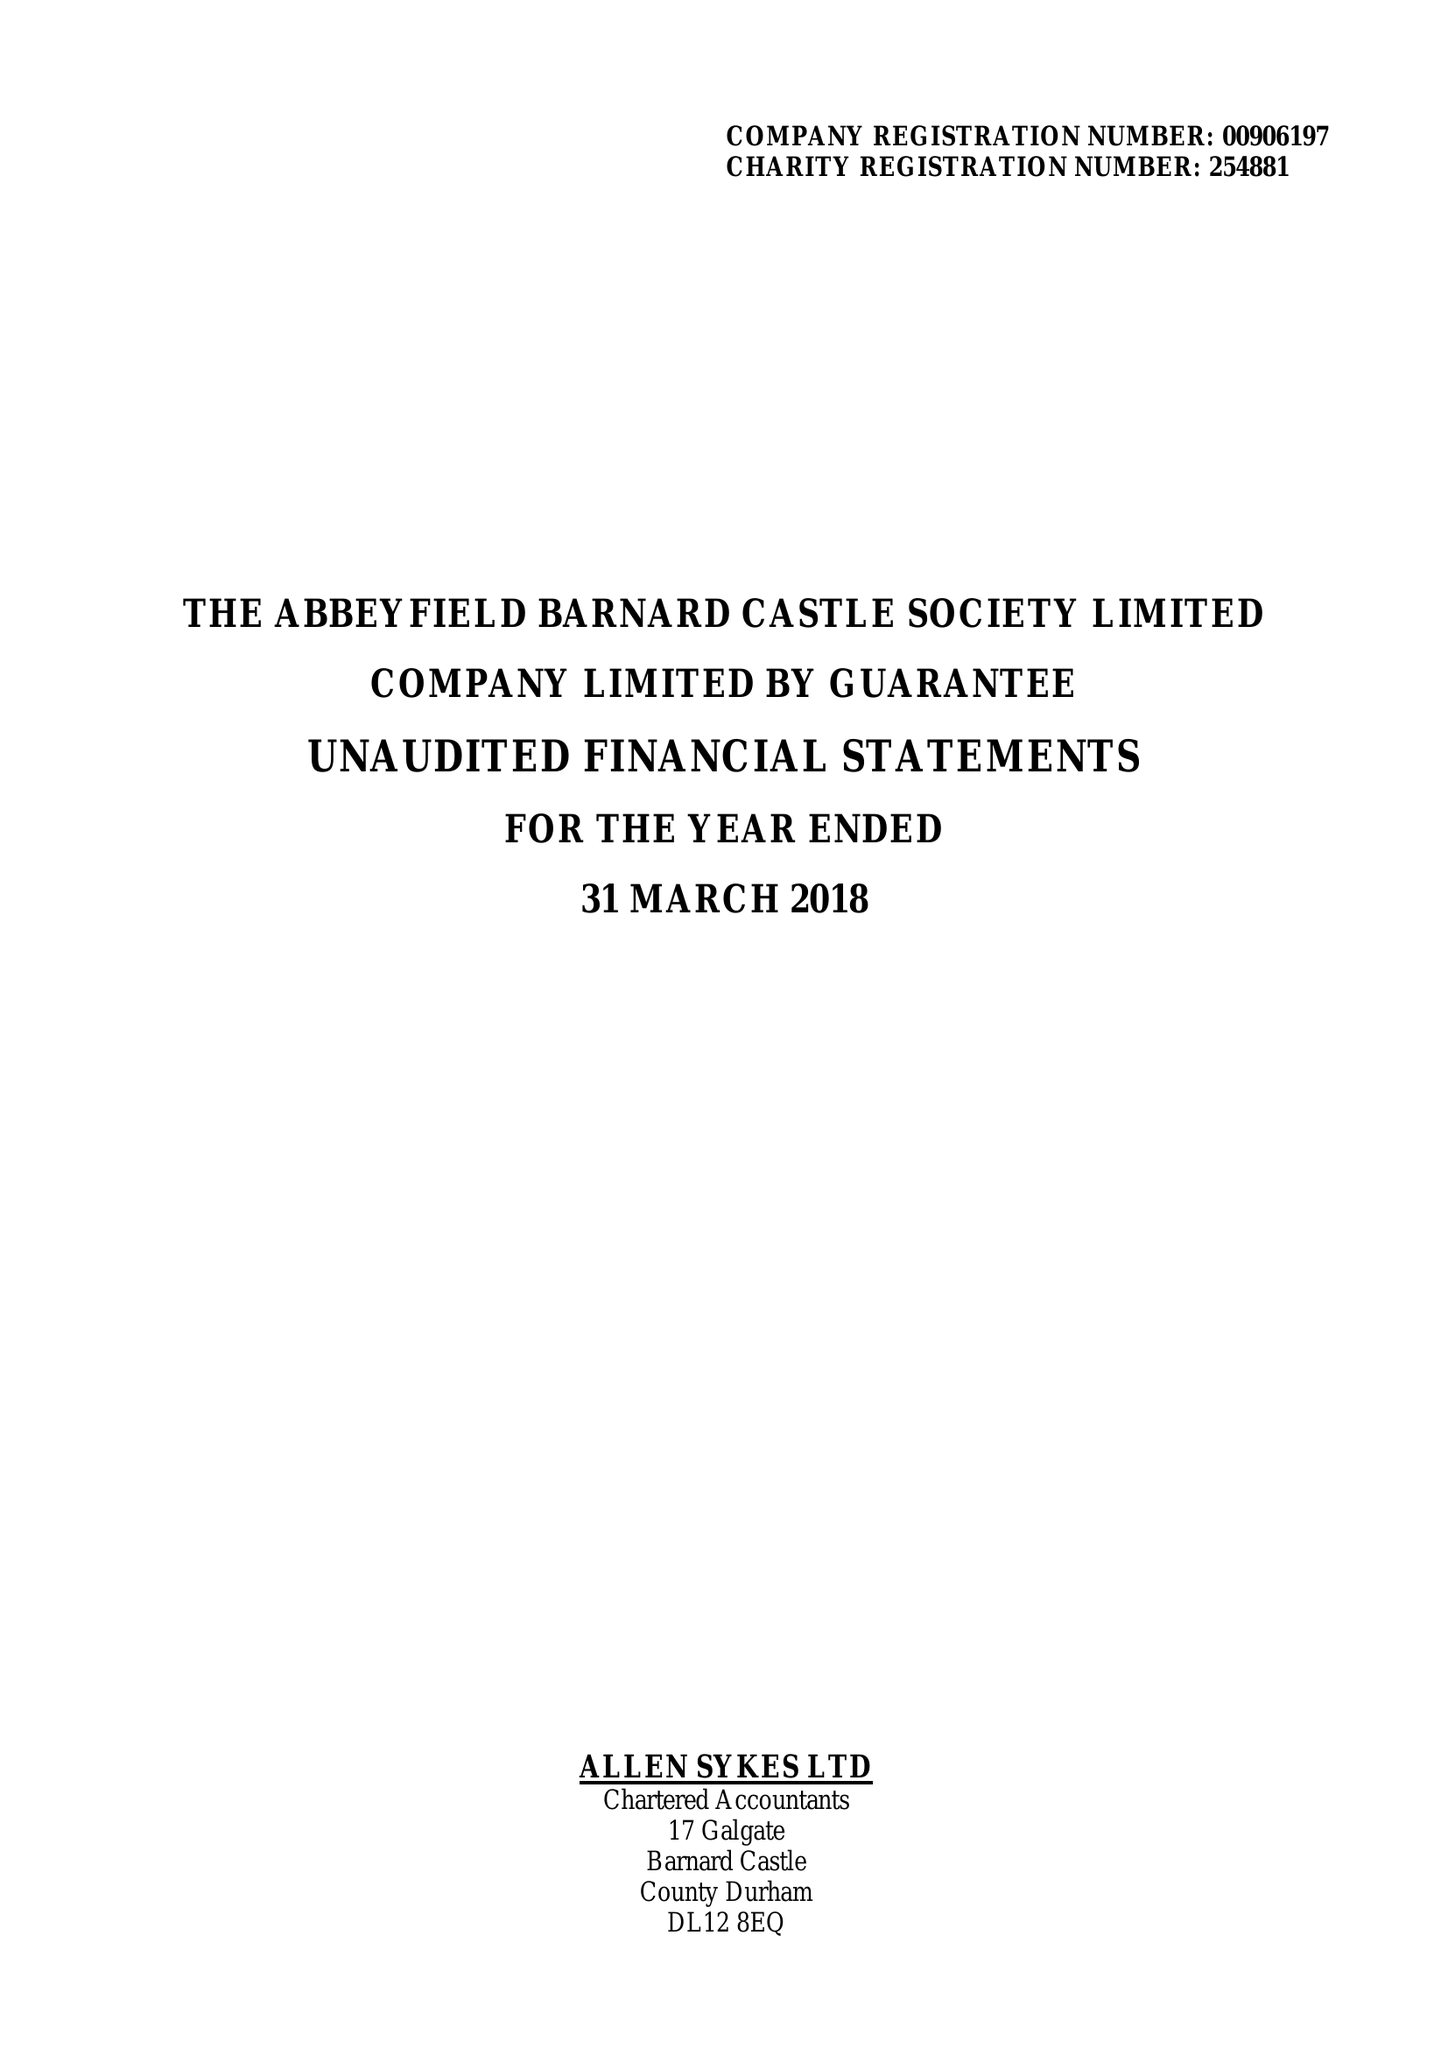What is the value for the spending_annually_in_british_pounds?
Answer the question using a single word or phrase. 138010.00 